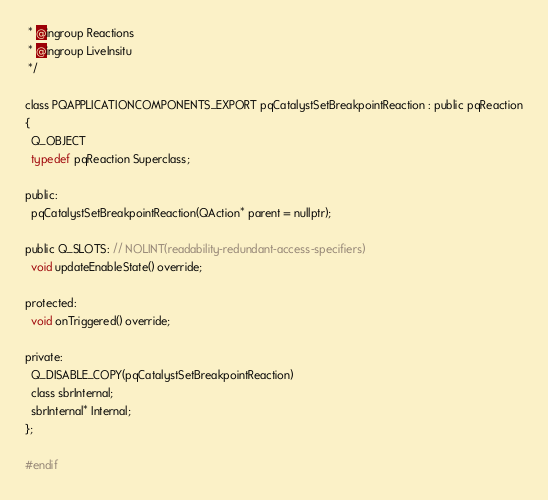Convert code to text. <code><loc_0><loc_0><loc_500><loc_500><_C_> * @ingroup Reactions
 * @ingroup LiveInsitu
 */

class PQAPPLICATIONCOMPONENTS_EXPORT pqCatalystSetBreakpointReaction : public pqReaction
{
  Q_OBJECT
  typedef pqReaction Superclass;

public:
  pqCatalystSetBreakpointReaction(QAction* parent = nullptr);

public Q_SLOTS: // NOLINT(readability-redundant-access-specifiers)
  void updateEnableState() override;

protected:
  void onTriggered() override;

private:
  Q_DISABLE_COPY(pqCatalystSetBreakpointReaction)
  class sbrInternal;
  sbrInternal* Internal;
};

#endif
</code> 